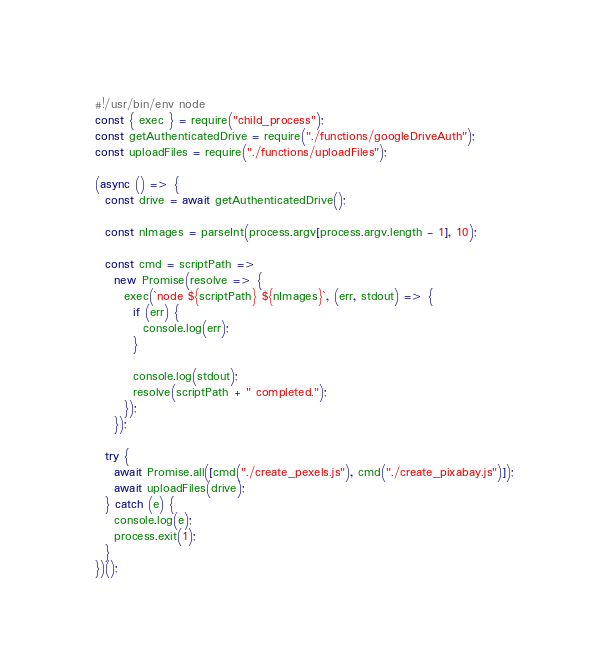<code> <loc_0><loc_0><loc_500><loc_500><_JavaScript_>#!/usr/bin/env node
const { exec } = require("child_process");
const getAuthenticatedDrive = require("./functions/googleDriveAuth");
const uploadFiles = require("./functions/uploadFiles");

(async () => {
  const drive = await getAuthenticatedDrive();

  const nImages = parseInt(process.argv[process.argv.length - 1], 10);

  const cmd = scriptPath =>
    new Promise(resolve => {
      exec(`node ${scriptPath} ${nImages}`, (err, stdout) => {
        if (err) {
          console.log(err);
        }

        console.log(stdout);
        resolve(scriptPath + " completed.");
      });
    });

  try {
    await Promise.all([cmd("./create_pexels.js"), cmd("./create_pixabay.js")]);
    await uploadFiles(drive);
  } catch (e) {
    console.log(e);
    process.exit(1);
  }
})();
</code> 